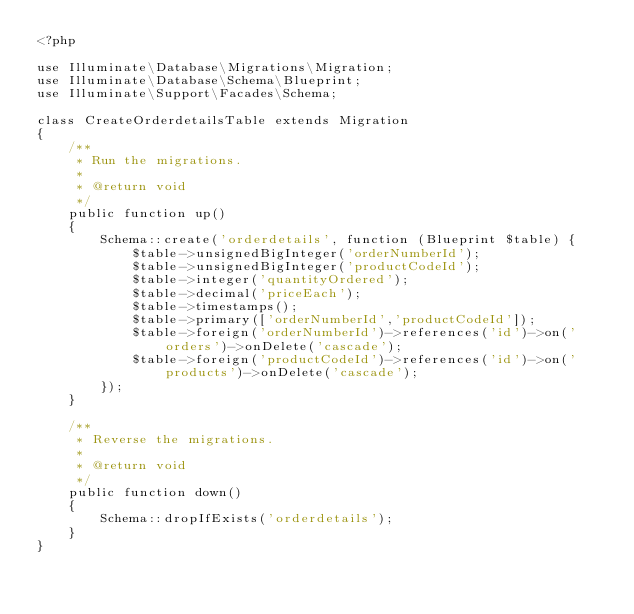<code> <loc_0><loc_0><loc_500><loc_500><_PHP_><?php

use Illuminate\Database\Migrations\Migration;
use Illuminate\Database\Schema\Blueprint;
use Illuminate\Support\Facades\Schema;

class CreateOrderdetailsTable extends Migration
{
    /**
     * Run the migrations.
     *
     * @return void
     */
    public function up()
    {
        Schema::create('orderdetails', function (Blueprint $table) {
            $table->unsignedBigInteger('orderNumberId');
            $table->unsignedBigInteger('productCodeId');
            $table->integer('quantityOrdered');
            $table->decimal('priceEach');
            $table->timestamps();
            $table->primary(['orderNumberId','productCodeId']);
            $table->foreign('orderNumberId')->references('id')->on('orders')->onDelete('cascade');
            $table->foreign('productCodeId')->references('id')->on('products')->onDelete('cascade');
        });
    }

    /**
     * Reverse the migrations.
     *
     * @return void
     */
    public function down()
    {
        Schema::dropIfExists('orderdetails');
    }
}
</code> 